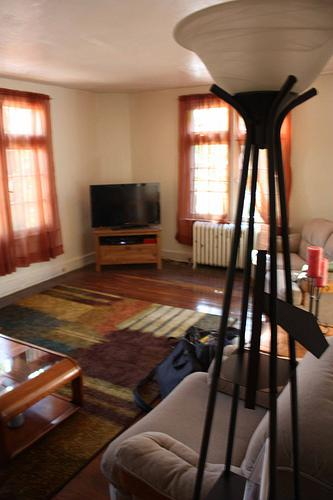Question: what color are the candles?
Choices:
A. Blue.
B. Black.
C. Red.
D. Green.
Answer with the letter. Answer: C Question: where was this photo taken?
Choices:
A. Outside.
B. The beach.
C. A house.
D. In a living room.
Answer with the letter. Answer: D Question: how many candles are there?
Choices:
A. 3.
B. 4.
C. 5.
D. 2.
Answer with the letter. Answer: D Question: what is covering the windows?
Choices:
A. Decoration.
B. Paintings.
C. Paper.
D. Curtains.
Answer with the letter. Answer: D 